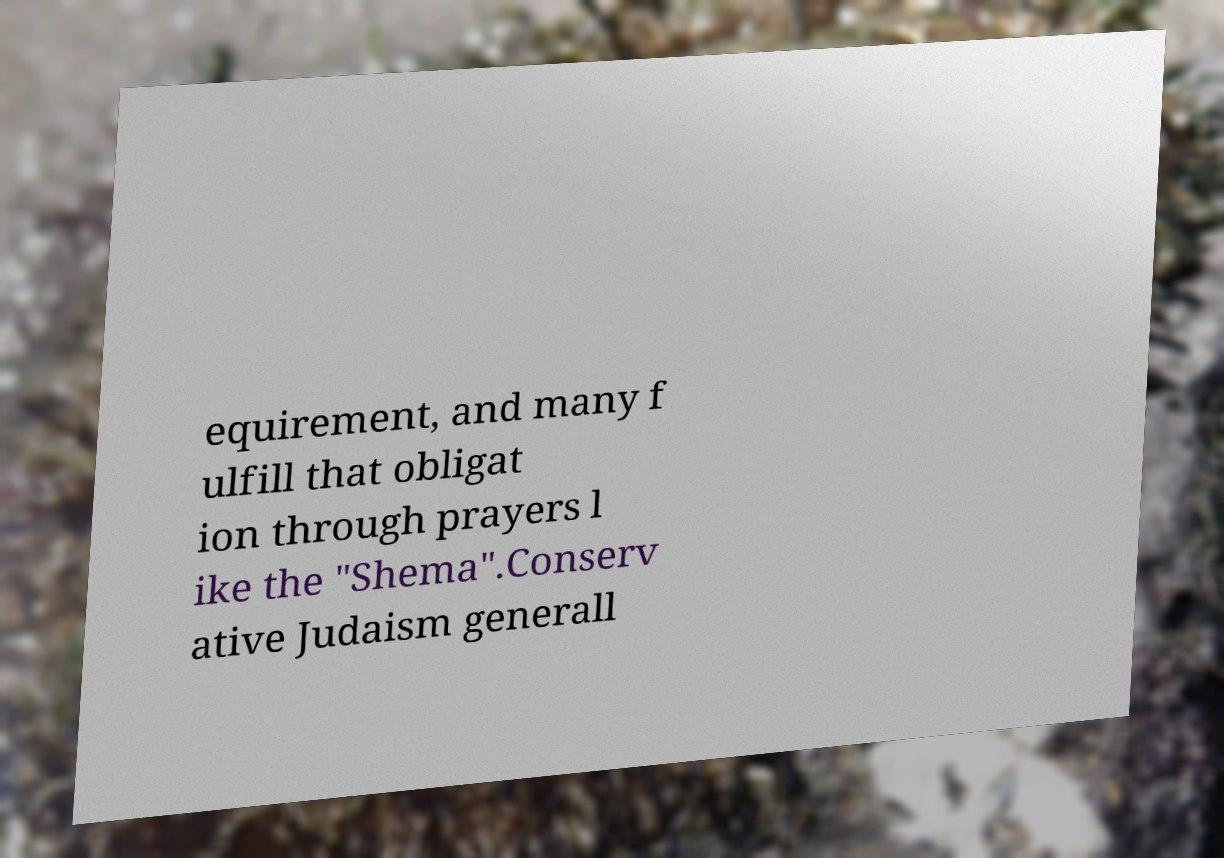Can you accurately transcribe the text from the provided image for me? equirement, and many f ulfill that obligat ion through prayers l ike the "Shema".Conserv ative Judaism generall 